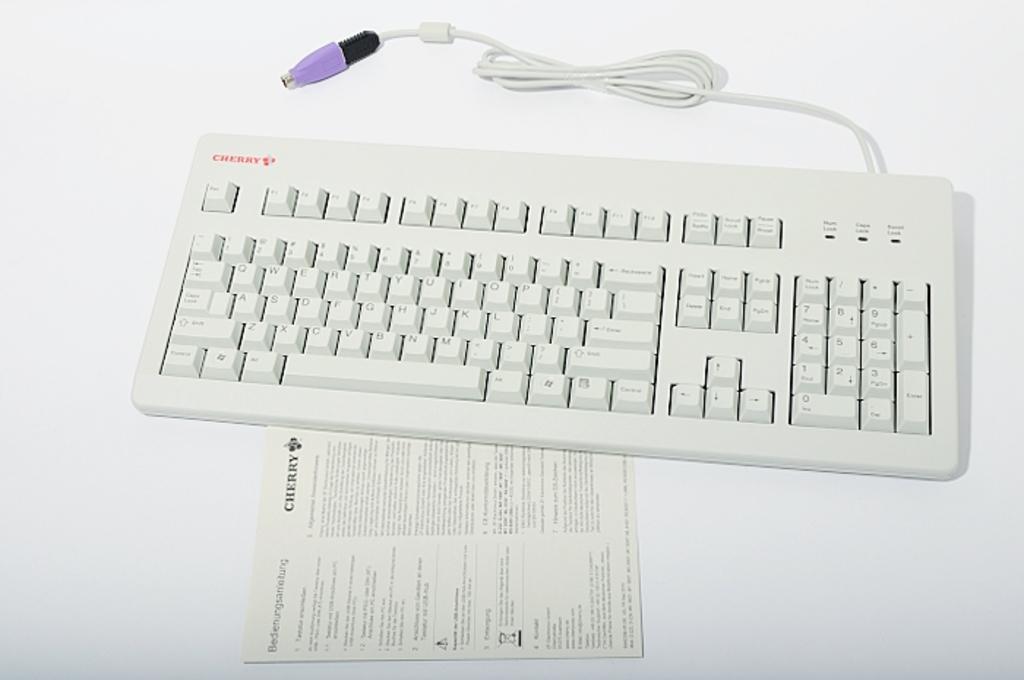Could you give a brief overview of what you see in this image? In this image in the center there is one keyboard and one paper. 